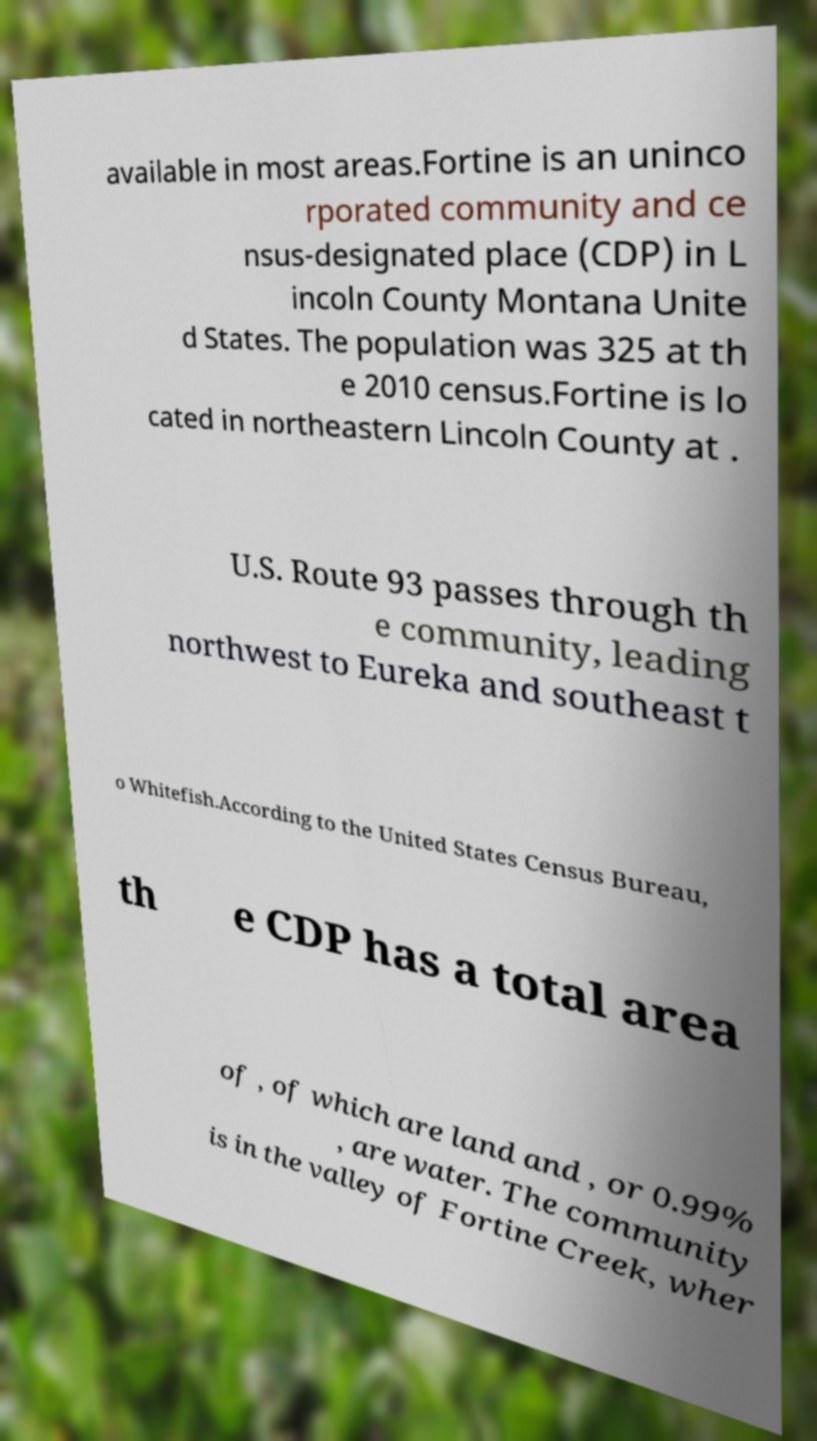What messages or text are displayed in this image? I need them in a readable, typed format. available in most areas.Fortine is an uninco rporated community and ce nsus-designated place (CDP) in L incoln County Montana Unite d States. The population was 325 at th e 2010 census.Fortine is lo cated in northeastern Lincoln County at . U.S. Route 93 passes through th e community, leading northwest to Eureka and southeast t o Whitefish.According to the United States Census Bureau, th e CDP has a total area of , of which are land and , or 0.99% , are water. The community is in the valley of Fortine Creek, wher 